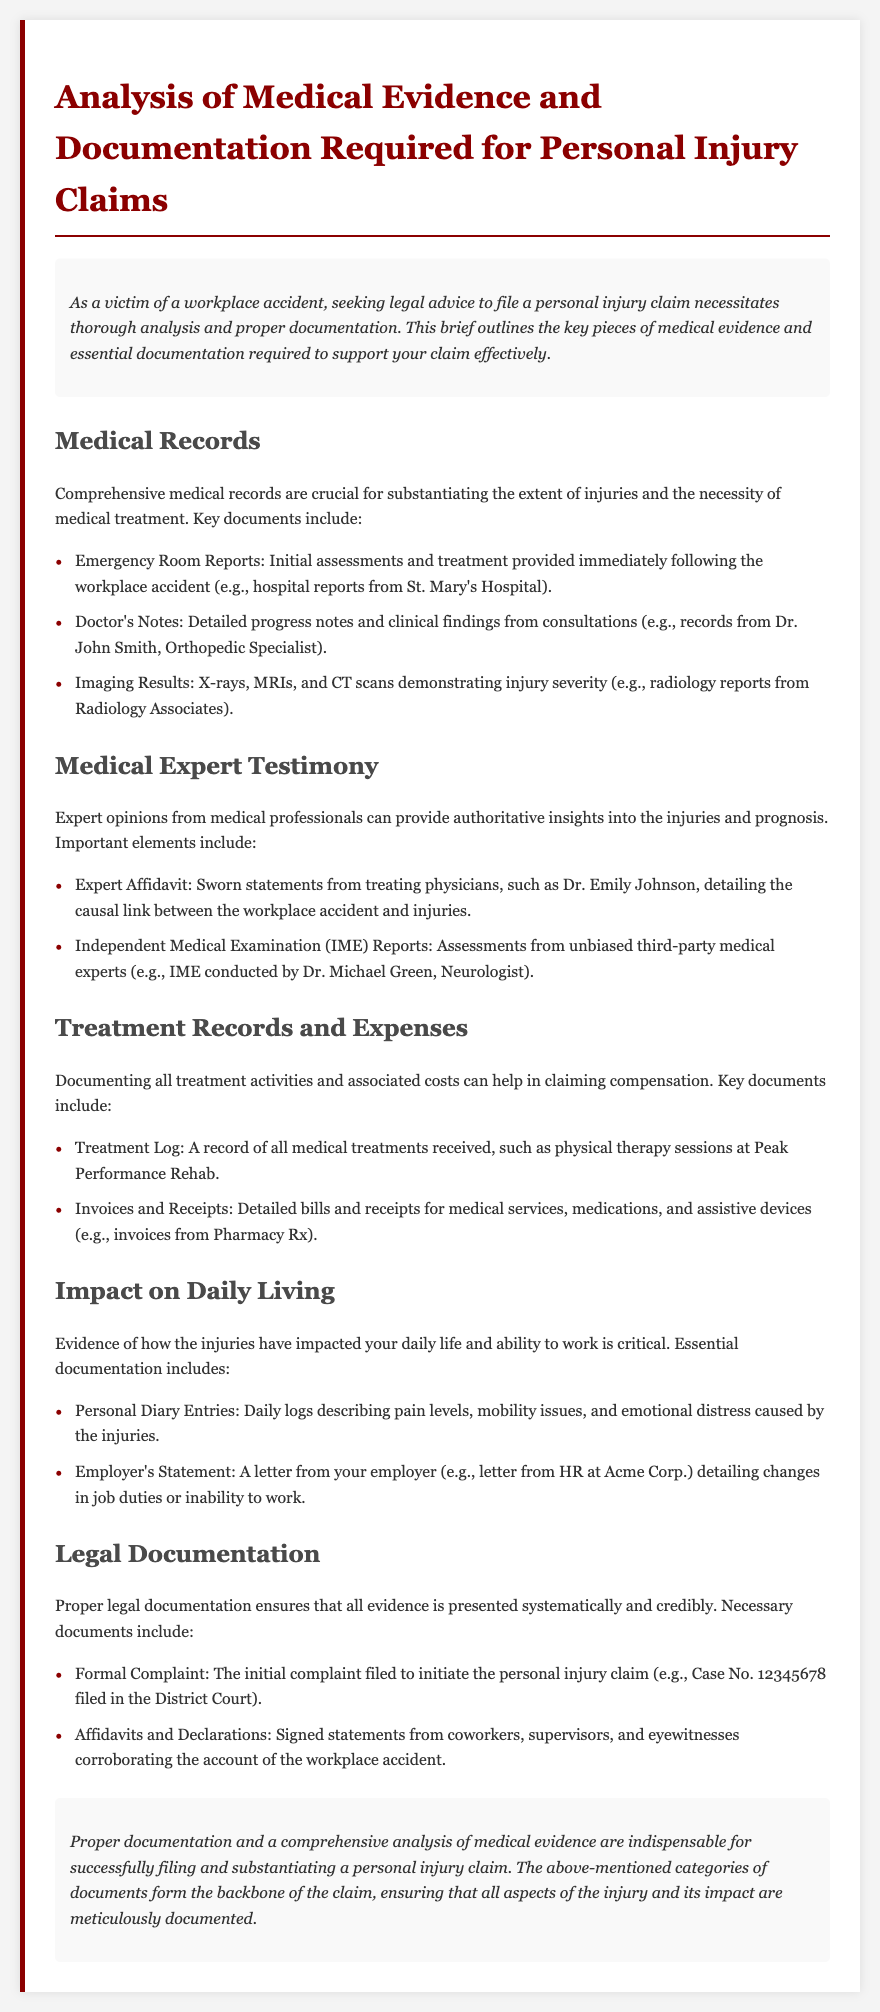What are the key documents for medical records? Medical records are crucial for substantiating injuries and necessary treatment. Key documents include Emergency Room Reports, Doctor's Notes, and Imaging Results.
Answer: Emergency Room Reports, Doctor's Notes, Imaging Results Who provides the expert affidavit? The expert affidavit is a sworn statement detailing the causal link between the workplace accident and injuries. It is provided by treating physicians.
Answer: Treating physicians What is an essential document for treatment records? Treatment records must document all medical treatments received, including physical therapy sessions.
Answer: Treatment Log What can demonstrate the impact on daily living? Evidence showing how injuries affect daily life and work ability can be documented through personal diary entries and an employer's statement.
Answer: Personal diary entries, Employer's statement What type of document initiates a personal injury claim? The formal complaint is the document filed to initiate the personal injury claim.
Answer: Formal Complaint How many key categories of documents are mentioned? The document outlines specific categories that are critical for a personal injury claim. There are five key categories mentioned.
Answer: Five What is the purpose of medical expert testimony? Medical expert testimony provides authoritative insights into the injuries and prognosis following a workplace accident.
Answer: Authoritative insights What type of documentation corroborates the account of the accident? Affidavits and declarations signed by coworkers, supervisors, and eyewitnesses serve to corroborate the account of the workplace accident.
Answer: Affidavits and Declarations Which hospital report is mentioned as part of medical records? The emergency room reports provide the initial assessments and treatment details after the accident. An example mentioned is the report from St. Mary's Hospital.
Answer: St. Mary's Hospital 